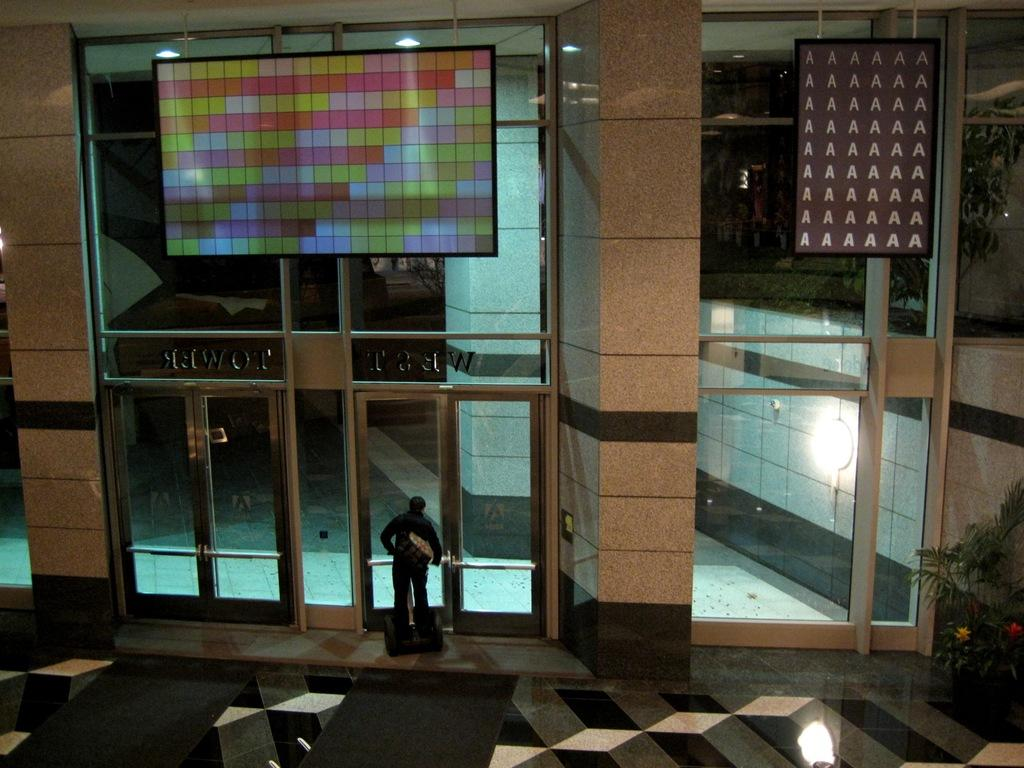What is the main subject in the foreground of the image? There is a person on the floor in the foreground of the image. What else can be seen in the foreground of the image? There are houseplants in the foreground of the image. What is visible in the background of the image? There is a door, boards, and a wall in the background of the image. Where was the image taken? The image was taken inside a building. What type of cream is being offered by the person in the image? There is no cream or offering present in the image; it only shows a person on the floor and houseplants in the foreground, with a door, boards, and wall in the background. 